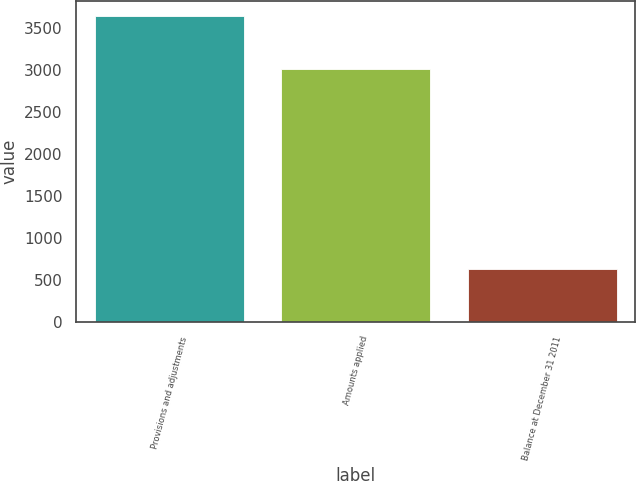<chart> <loc_0><loc_0><loc_500><loc_500><bar_chart><fcel>Provisions and adjustments<fcel>Amounts applied<fcel>Balance at December 31 2011<nl><fcel>3645<fcel>3010<fcel>635<nl></chart> 